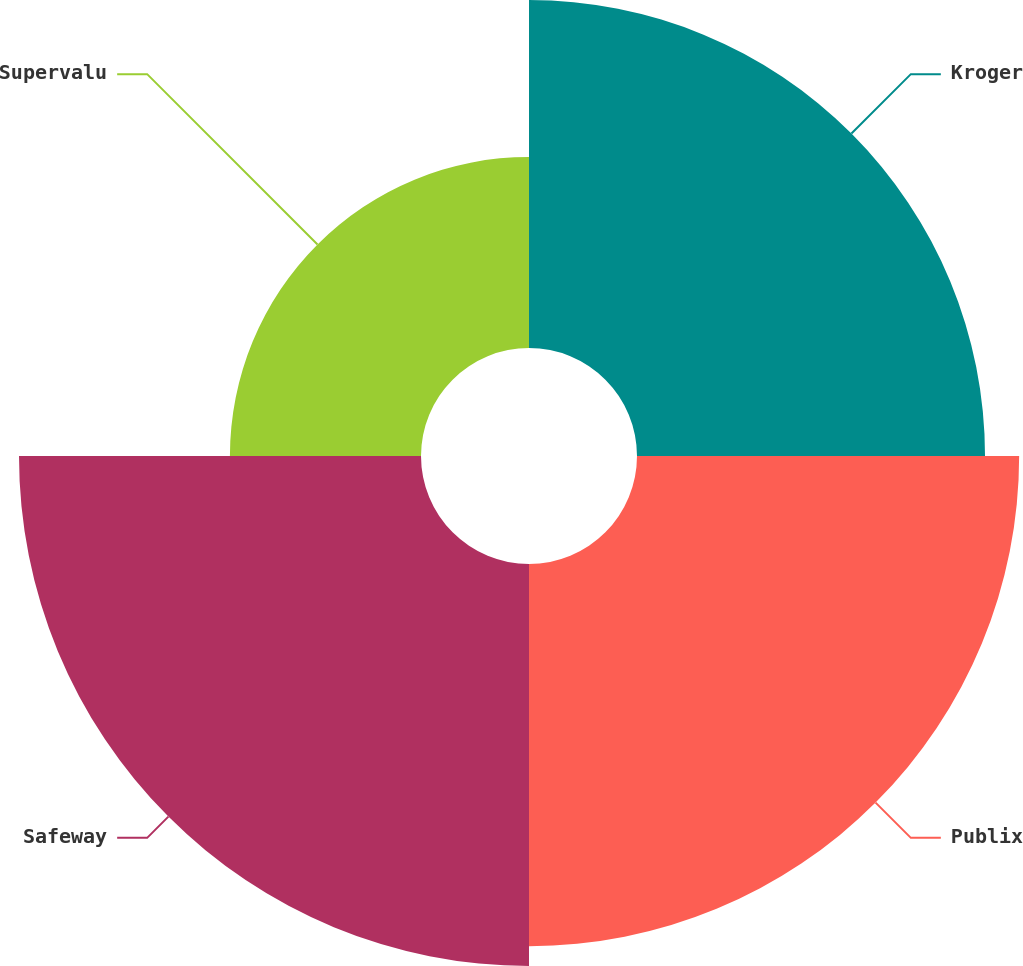<chart> <loc_0><loc_0><loc_500><loc_500><pie_chart><fcel>Kroger<fcel>Publix<fcel>Safeway<fcel>Supervalu<nl><fcel>26.3%<fcel>28.88%<fcel>30.38%<fcel>14.44%<nl></chart> 